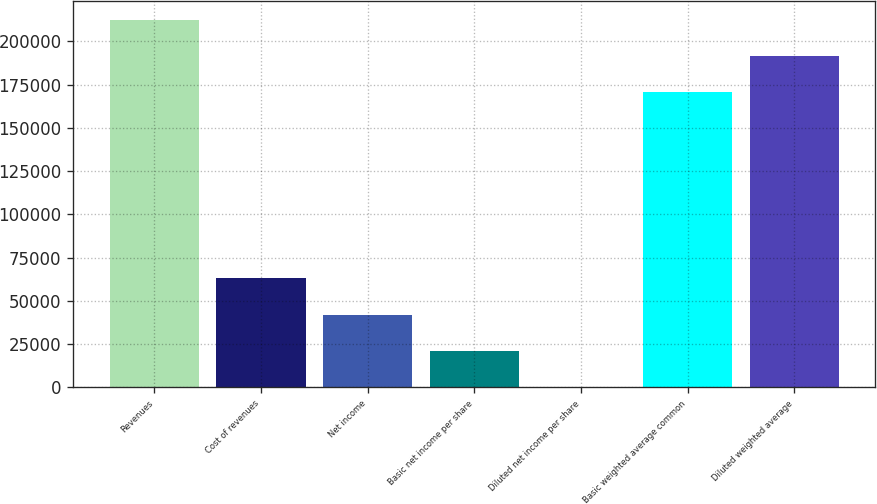Convert chart to OTSL. <chart><loc_0><loc_0><loc_500><loc_500><bar_chart><fcel>Revenues<fcel>Cost of revenues<fcel>Net income<fcel>Basic net income per share<fcel>Diluted net income per share<fcel>Basic weighted average common<fcel>Diluted weighted average<nl><fcel>212593<fcel>63110.5<fcel>42073.8<fcel>21037<fcel>0.2<fcel>170519<fcel>191556<nl></chart> 